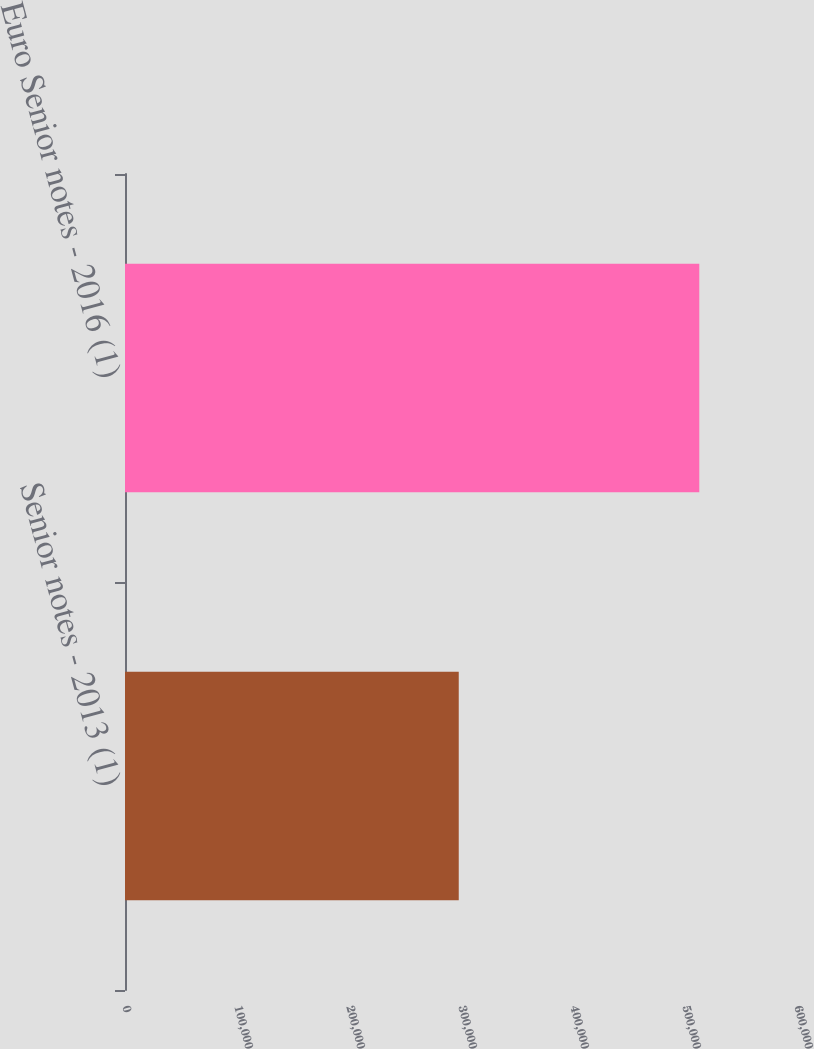Convert chart to OTSL. <chart><loc_0><loc_0><loc_500><loc_500><bar_chart><fcel>Senior notes - 2013 (1)<fcel>Euro Senior notes - 2016 (1)<nl><fcel>297986<fcel>512764<nl></chart> 